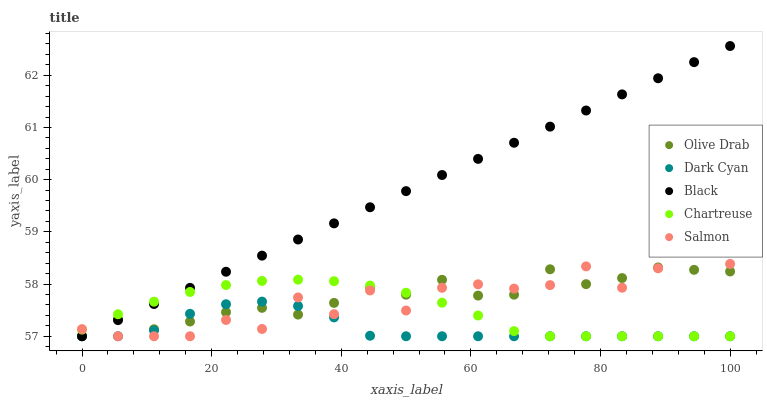Does Dark Cyan have the minimum area under the curve?
Answer yes or no. Yes. Does Black have the maximum area under the curve?
Answer yes or no. Yes. Does Salmon have the minimum area under the curve?
Answer yes or no. No. Does Salmon have the maximum area under the curve?
Answer yes or no. No. Is Black the smoothest?
Answer yes or no. Yes. Is Salmon the roughest?
Answer yes or no. Yes. Is Chartreuse the smoothest?
Answer yes or no. No. Is Chartreuse the roughest?
Answer yes or no. No. Does Dark Cyan have the lowest value?
Answer yes or no. Yes. Does Black have the highest value?
Answer yes or no. Yes. Does Salmon have the highest value?
Answer yes or no. No. Does Dark Cyan intersect Olive Drab?
Answer yes or no. Yes. Is Dark Cyan less than Olive Drab?
Answer yes or no. No. Is Dark Cyan greater than Olive Drab?
Answer yes or no. No. 